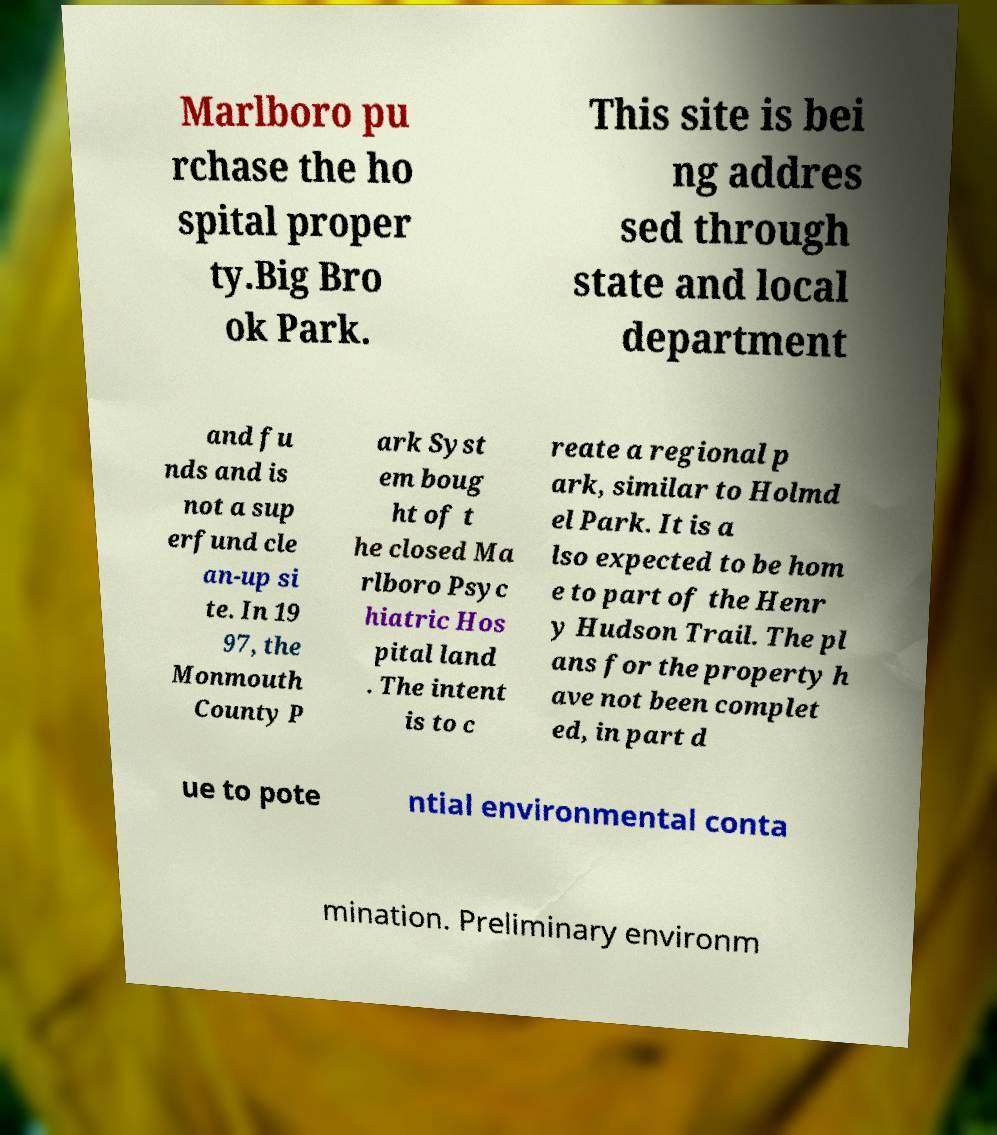Can you read and provide the text displayed in the image?This photo seems to have some interesting text. Can you extract and type it out for me? Marlboro pu rchase the ho spital proper ty.Big Bro ok Park. This site is bei ng addres sed through state and local department and fu nds and is not a sup erfund cle an-up si te. In 19 97, the Monmouth County P ark Syst em boug ht of t he closed Ma rlboro Psyc hiatric Hos pital land . The intent is to c reate a regional p ark, similar to Holmd el Park. It is a lso expected to be hom e to part of the Henr y Hudson Trail. The pl ans for the property h ave not been complet ed, in part d ue to pote ntial environmental conta mination. Preliminary environm 